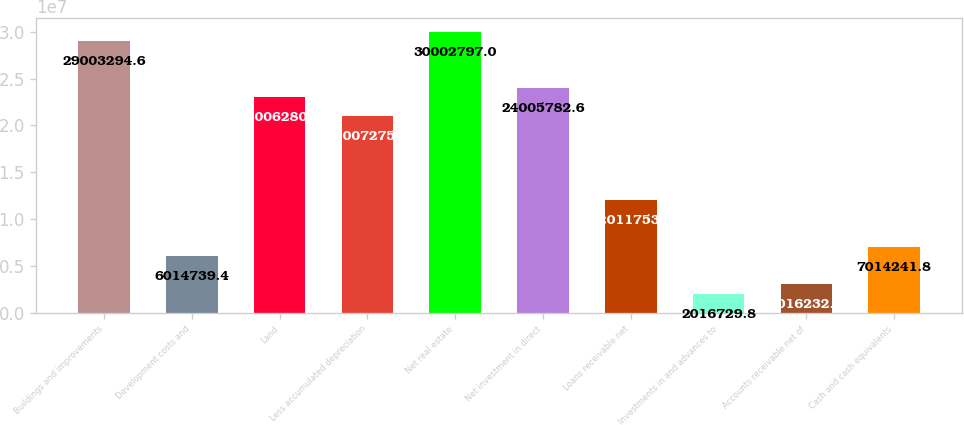Convert chart. <chart><loc_0><loc_0><loc_500><loc_500><bar_chart><fcel>Buildings and improvements<fcel>Development costs and<fcel>Land<fcel>Less accumulated depreciation<fcel>Net real estate<fcel>Net investment in direct<fcel>Loans receivable net<fcel>Investments in and advances to<fcel>Accounts receivable net of<fcel>Cash and cash equivalents<nl><fcel>2.90033e+07<fcel>6.01474e+06<fcel>2.30063e+07<fcel>2.10073e+07<fcel>3.00028e+07<fcel>2.40058e+07<fcel>1.20118e+07<fcel>2.01673e+06<fcel>3.01623e+06<fcel>7.01424e+06<nl></chart> 